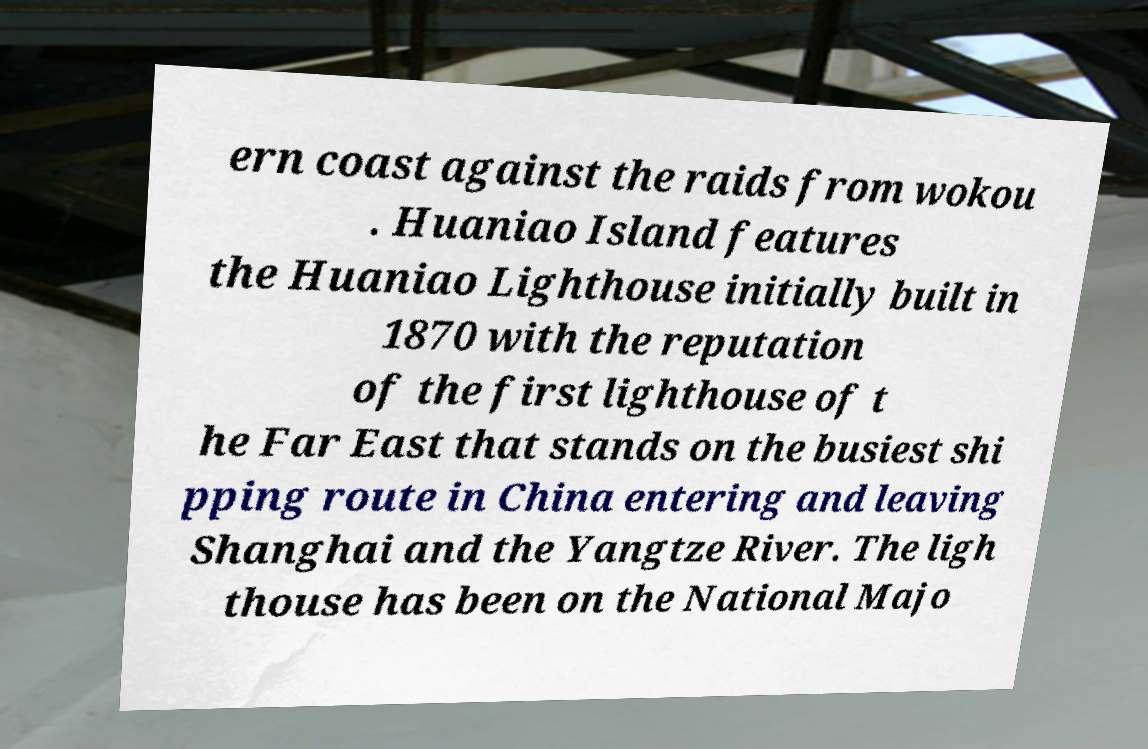Could you assist in decoding the text presented in this image and type it out clearly? ern coast against the raids from wokou . Huaniao Island features the Huaniao Lighthouse initially built in 1870 with the reputation of the first lighthouse of t he Far East that stands on the busiest shi pping route in China entering and leaving Shanghai and the Yangtze River. The ligh thouse has been on the National Majo 